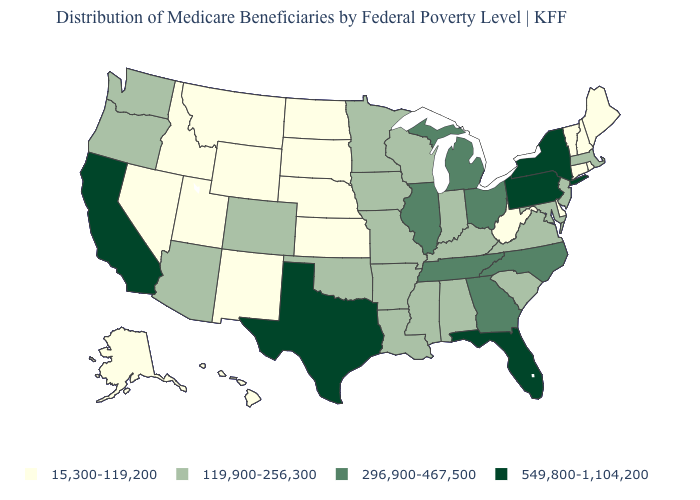What is the lowest value in the USA?
Be succinct. 15,300-119,200. Name the states that have a value in the range 15,300-119,200?
Quick response, please. Alaska, Connecticut, Delaware, Hawaii, Idaho, Kansas, Maine, Montana, Nebraska, Nevada, New Hampshire, New Mexico, North Dakota, Rhode Island, South Dakota, Utah, Vermont, West Virginia, Wyoming. What is the value of Nebraska?
Keep it brief. 15,300-119,200. What is the value of South Carolina?
Give a very brief answer. 119,900-256,300. Name the states that have a value in the range 549,800-1,104,200?
Short answer required. California, Florida, New York, Pennsylvania, Texas. Does Indiana have the highest value in the MidWest?
Concise answer only. No. Is the legend a continuous bar?
Concise answer only. No. What is the lowest value in the MidWest?
Be succinct. 15,300-119,200. What is the lowest value in states that border Illinois?
Quick response, please. 119,900-256,300. What is the lowest value in the MidWest?
Be succinct. 15,300-119,200. Does Kentucky have the same value as Kansas?
Write a very short answer. No. Does Arkansas have a higher value than Vermont?
Give a very brief answer. Yes. What is the value of Virginia?
Give a very brief answer. 119,900-256,300. Does Minnesota have a lower value than Kentucky?
Give a very brief answer. No. Does the first symbol in the legend represent the smallest category?
Keep it brief. Yes. 